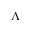Convert formula to latex. <formula><loc_0><loc_0><loc_500><loc_500>\Lambda</formula> 